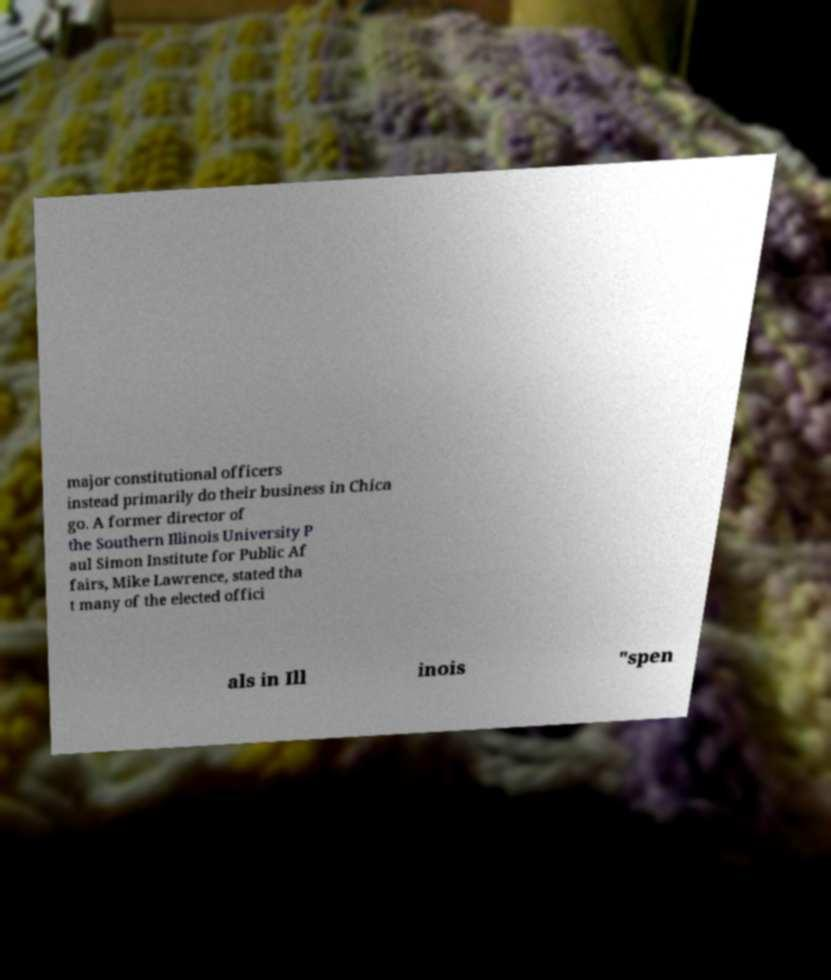There's text embedded in this image that I need extracted. Can you transcribe it verbatim? major constitutional officers instead primarily do their business in Chica go. A former director of the Southern Illinois University P aul Simon Institute for Public Af fairs, Mike Lawrence, stated tha t many of the elected offici als in Ill inois "spen 